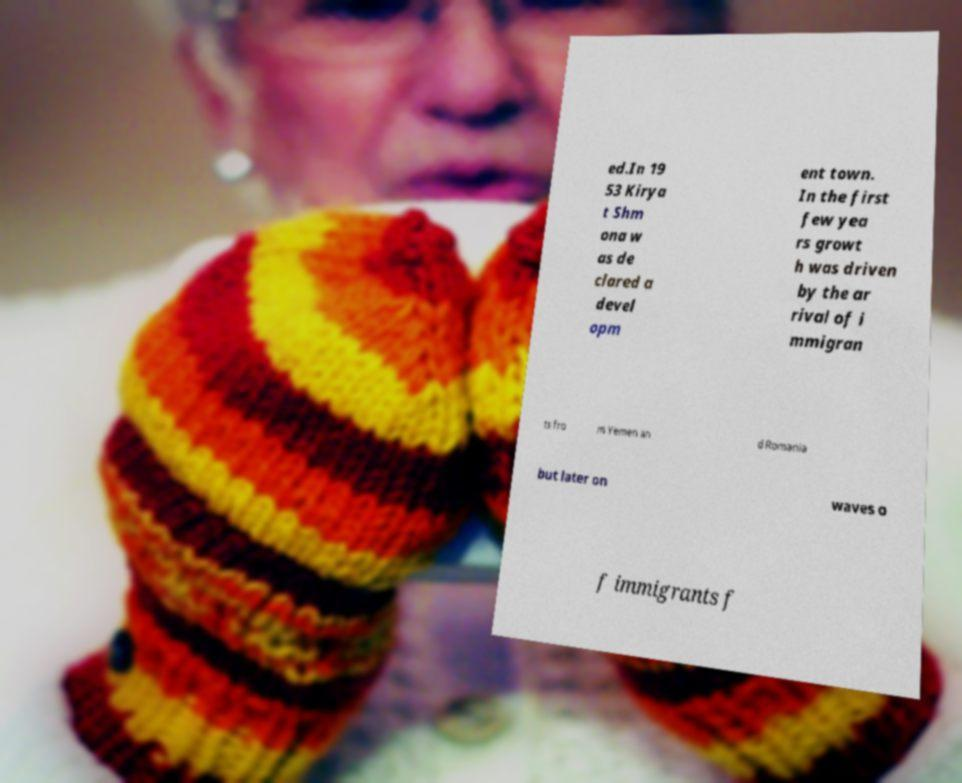There's text embedded in this image that I need extracted. Can you transcribe it verbatim? ed.In 19 53 Kirya t Shm ona w as de clared a devel opm ent town. In the first few yea rs growt h was driven by the ar rival of i mmigran ts fro m Yemen an d Romania but later on waves o f immigrants f 